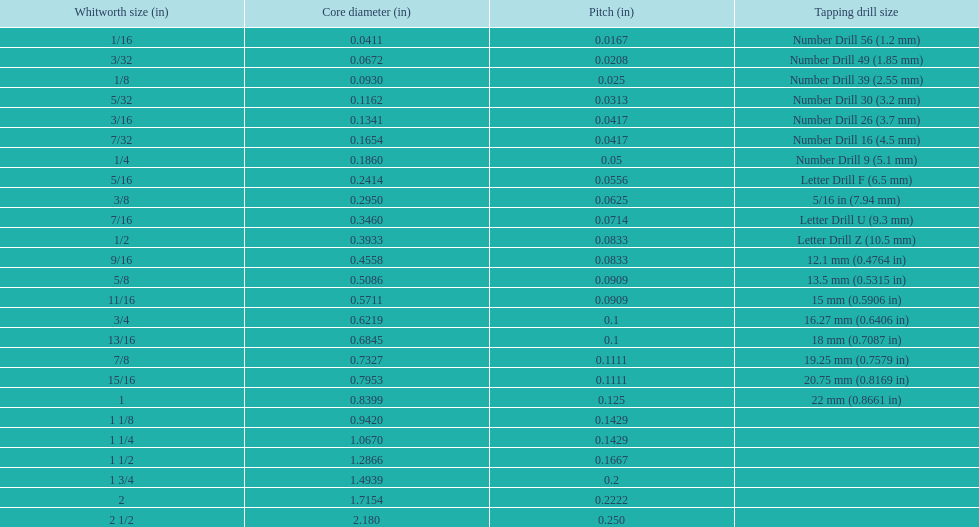How many more threads per inch does the 1/16th whitworth size have over the 1/8th whitworth size? 20. 